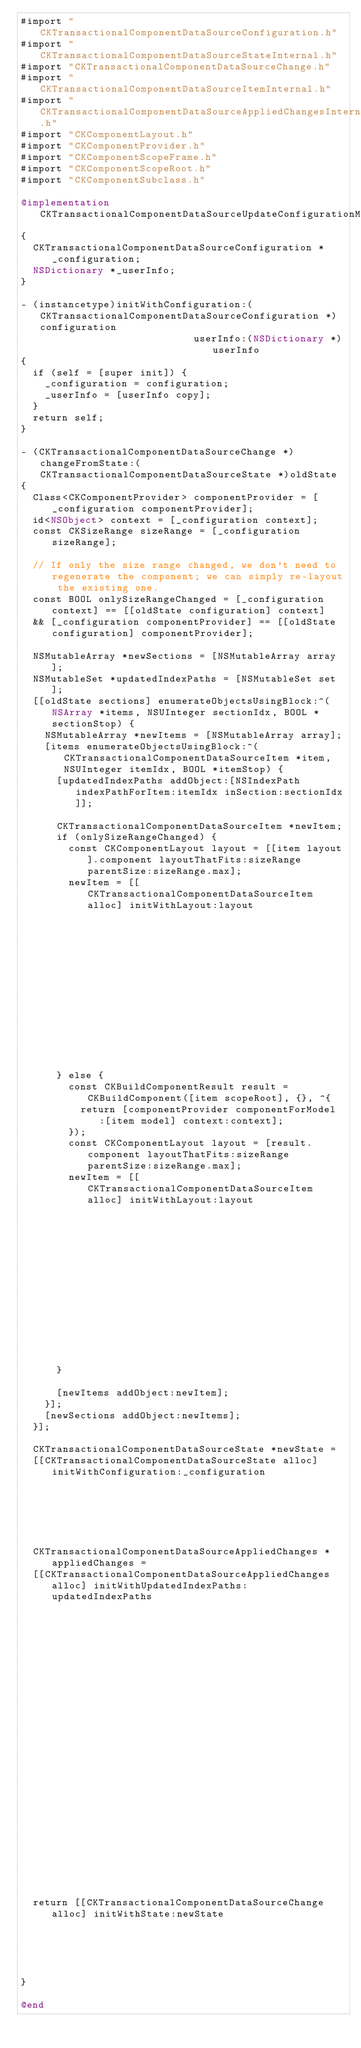<code> <loc_0><loc_0><loc_500><loc_500><_ObjectiveC_>#import "CKTransactionalComponentDataSourceConfiguration.h"
#import "CKTransactionalComponentDataSourceStateInternal.h"
#import "CKTransactionalComponentDataSourceChange.h"
#import "CKTransactionalComponentDataSourceItemInternal.h"
#import "CKTransactionalComponentDataSourceAppliedChangesInternal.h"
#import "CKComponentLayout.h"
#import "CKComponentProvider.h"
#import "CKComponentScopeFrame.h"
#import "CKComponentScopeRoot.h"
#import "CKComponentSubclass.h"

@implementation CKTransactionalComponentDataSourceUpdateConfigurationModification
{
  CKTransactionalComponentDataSourceConfiguration *_configuration;
  NSDictionary *_userInfo;
}

- (instancetype)initWithConfiguration:(CKTransactionalComponentDataSourceConfiguration *)configuration
                             userInfo:(NSDictionary *)userInfo
{
  if (self = [super init]) {
    _configuration = configuration;
    _userInfo = [userInfo copy];
  }
  return self;
}

- (CKTransactionalComponentDataSourceChange *)changeFromState:(CKTransactionalComponentDataSourceState *)oldState
{
  Class<CKComponentProvider> componentProvider = [_configuration componentProvider];
  id<NSObject> context = [_configuration context];
  const CKSizeRange sizeRange = [_configuration sizeRange];

  // If only the size range changed, we don't need to regenerate the component; we can simply re-layout the existing one.
  const BOOL onlySizeRangeChanged = [_configuration context] == [[oldState configuration] context]
  && [_configuration componentProvider] == [[oldState configuration] componentProvider];

  NSMutableArray *newSections = [NSMutableArray array];
  NSMutableSet *updatedIndexPaths = [NSMutableSet set];
  [[oldState sections] enumerateObjectsUsingBlock:^(NSArray *items, NSUInteger sectionIdx, BOOL *sectionStop) {
    NSMutableArray *newItems = [NSMutableArray array];
    [items enumerateObjectsUsingBlock:^(CKTransactionalComponentDataSourceItem *item, NSUInteger itemIdx, BOOL *itemStop) {
      [updatedIndexPaths addObject:[NSIndexPath indexPathForItem:itemIdx inSection:sectionIdx]];

      CKTransactionalComponentDataSourceItem *newItem;
      if (onlySizeRangeChanged) {
        const CKComponentLayout layout = [[item layout].component layoutThatFits:sizeRange parentSize:sizeRange.max];
        newItem = [[CKTransactionalComponentDataSourceItem alloc] initWithLayout:layout
                                                                           model:[item model]
                                                                       scopeRoot:[item scopeRoot]];
      } else {
        const CKBuildComponentResult result = CKBuildComponent([item scopeRoot], {}, ^{
          return [componentProvider componentForModel:[item model] context:context];
        });
        const CKComponentLayout layout = [result.component layoutThatFits:sizeRange parentSize:sizeRange.max];
        newItem = [[CKTransactionalComponentDataSourceItem alloc] initWithLayout:layout
                                                                           model:[item model]
                                                                       scopeRoot:result.scopeRoot];
      }

      [newItems addObject:newItem];
    }];
    [newSections addObject:newItems];
  }];

  CKTransactionalComponentDataSourceState *newState =
  [[CKTransactionalComponentDataSourceState alloc] initWithConfiguration:_configuration
                                                                sections:newSections];

  CKTransactionalComponentDataSourceAppliedChanges *appliedChanges =
  [[CKTransactionalComponentDataSourceAppliedChanges alloc] initWithUpdatedIndexPaths:updatedIndexPaths
                                                                    removedIndexPaths:nil
                                                                      removedSections:nil
                                                                      movedIndexPaths:nil
                                                                     insertedSections:nil
                                                                   insertedIndexPaths:nil
                                                                             userInfo:_userInfo];

  return [[CKTransactionalComponentDataSourceChange alloc] initWithState:newState
                                                          appliedChanges:appliedChanges];
}

@end
</code> 